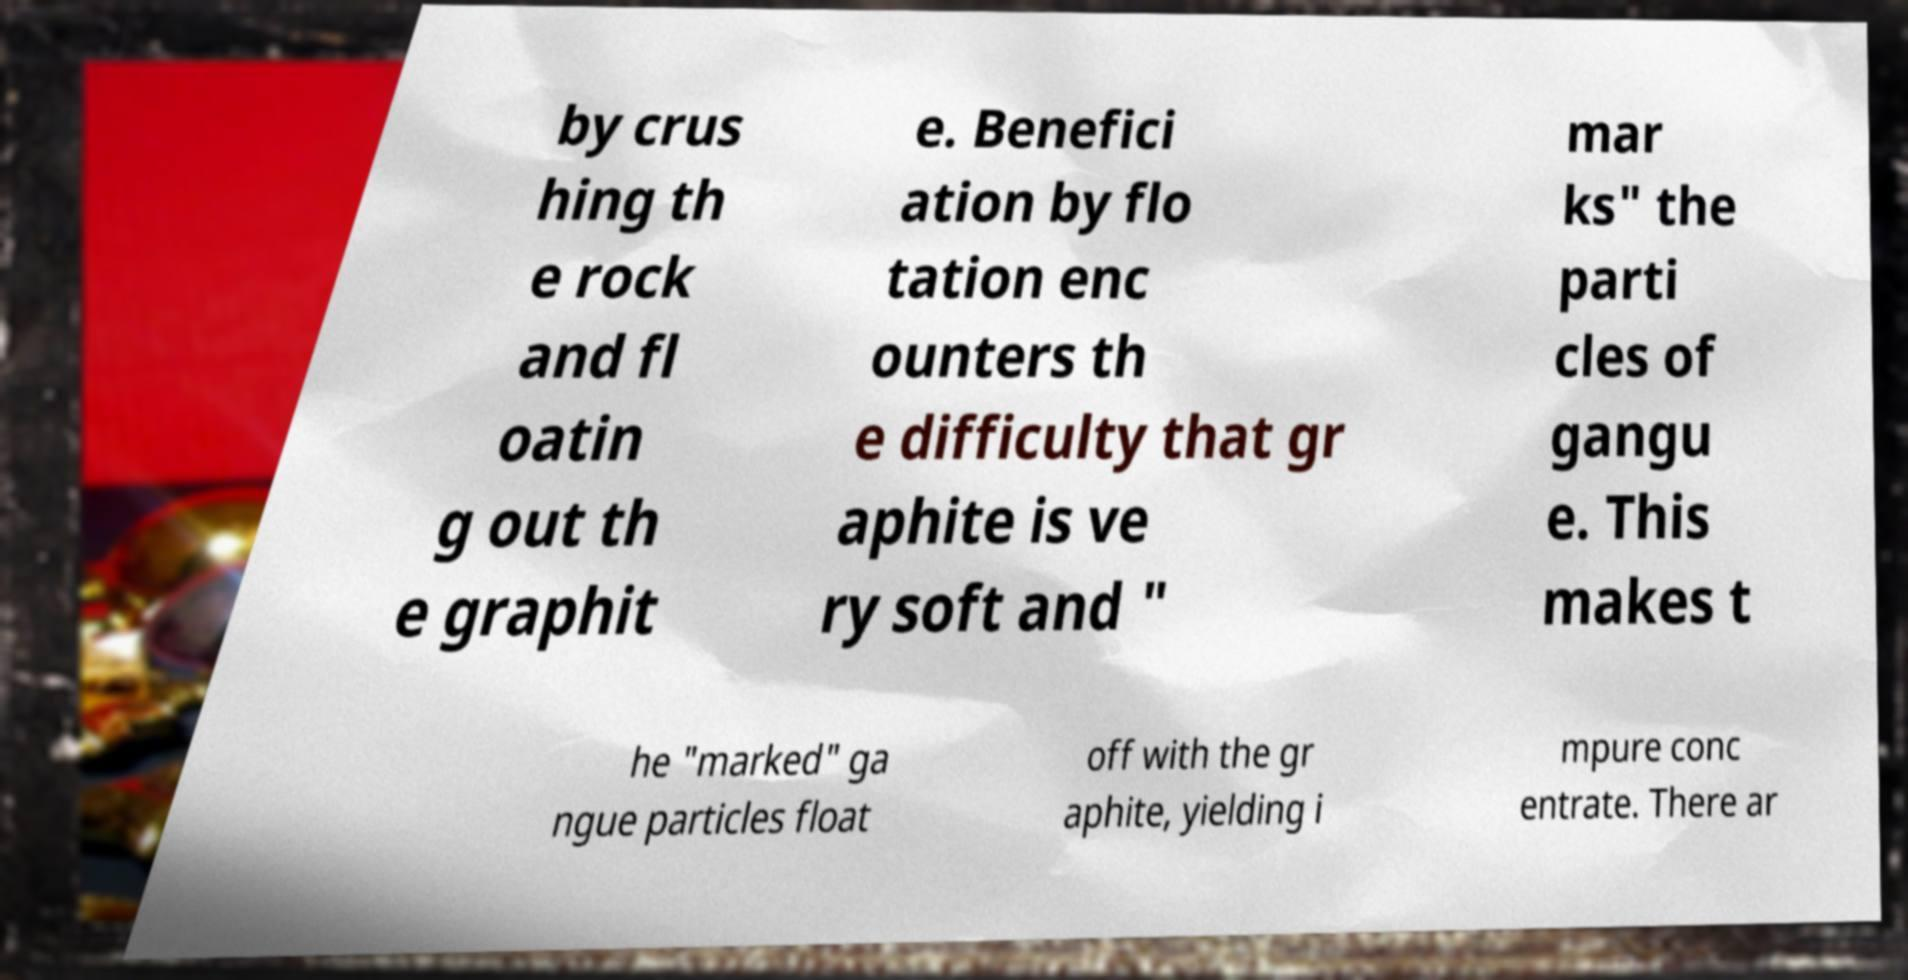Please identify and transcribe the text found in this image. by crus hing th e rock and fl oatin g out th e graphit e. Benefici ation by flo tation enc ounters th e difficulty that gr aphite is ve ry soft and " mar ks" the parti cles of gangu e. This makes t he "marked" ga ngue particles float off with the gr aphite, yielding i mpure conc entrate. There ar 